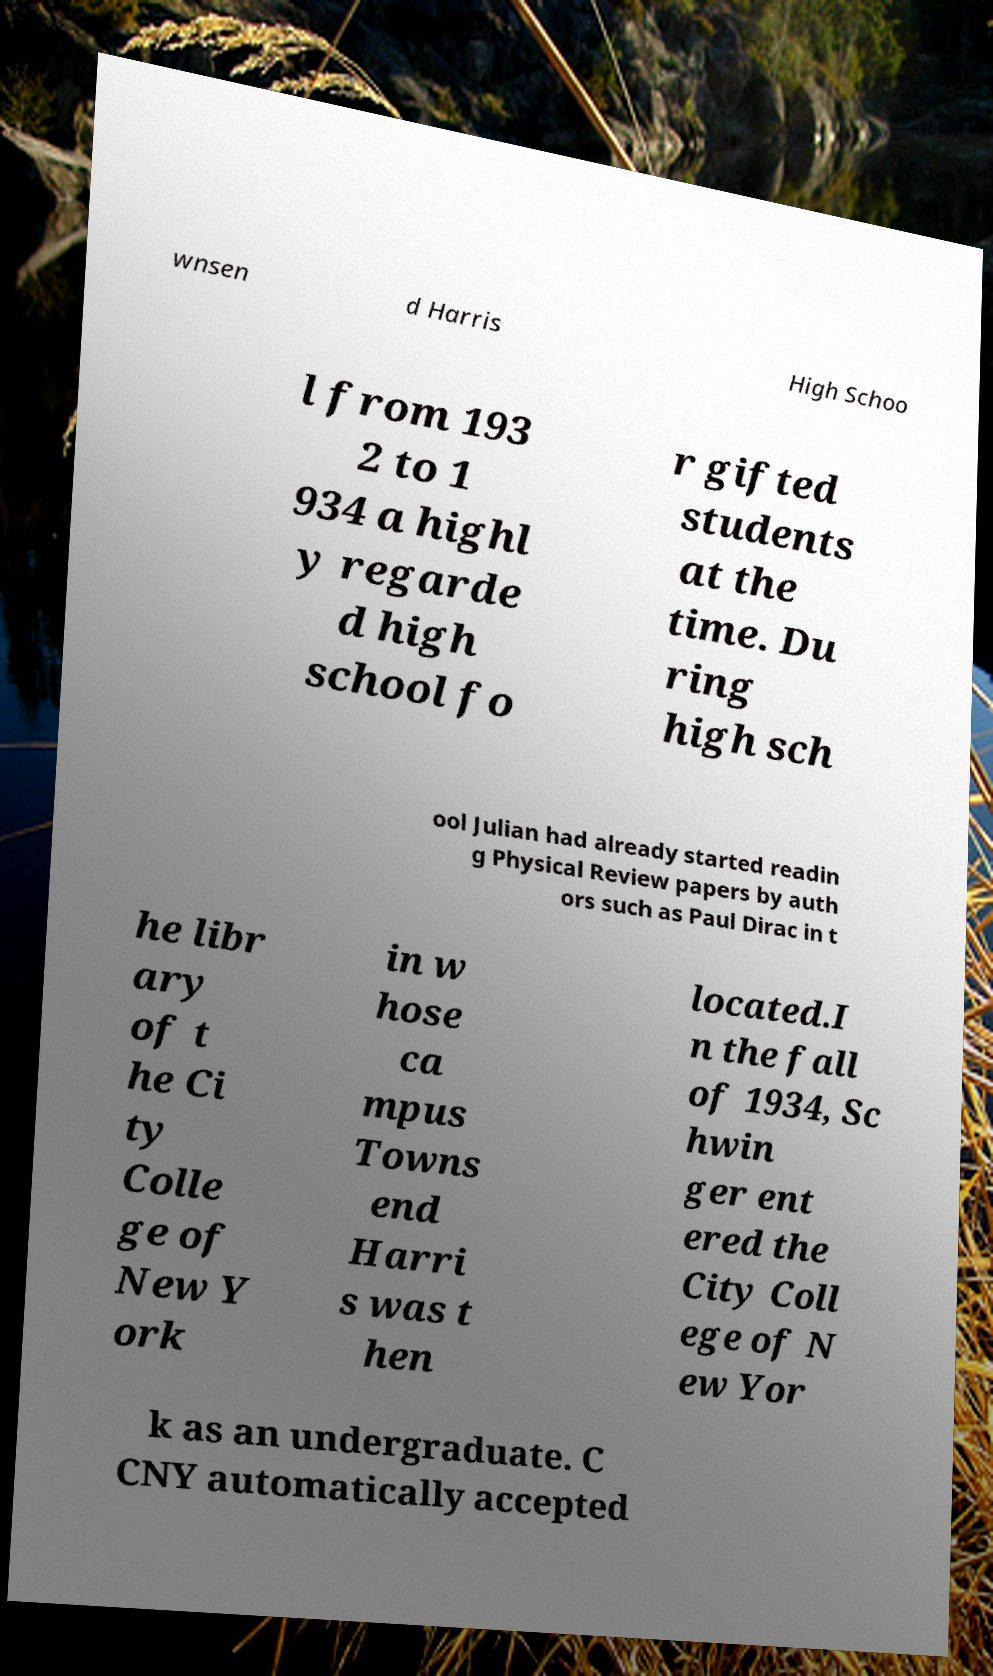What messages or text are displayed in this image? I need them in a readable, typed format. wnsen d Harris High Schoo l from 193 2 to 1 934 a highl y regarde d high school fo r gifted students at the time. Du ring high sch ool Julian had already started readin g Physical Review papers by auth ors such as Paul Dirac in t he libr ary of t he Ci ty Colle ge of New Y ork in w hose ca mpus Towns end Harri s was t hen located.I n the fall of 1934, Sc hwin ger ent ered the City Coll ege of N ew Yor k as an undergraduate. C CNY automatically accepted 